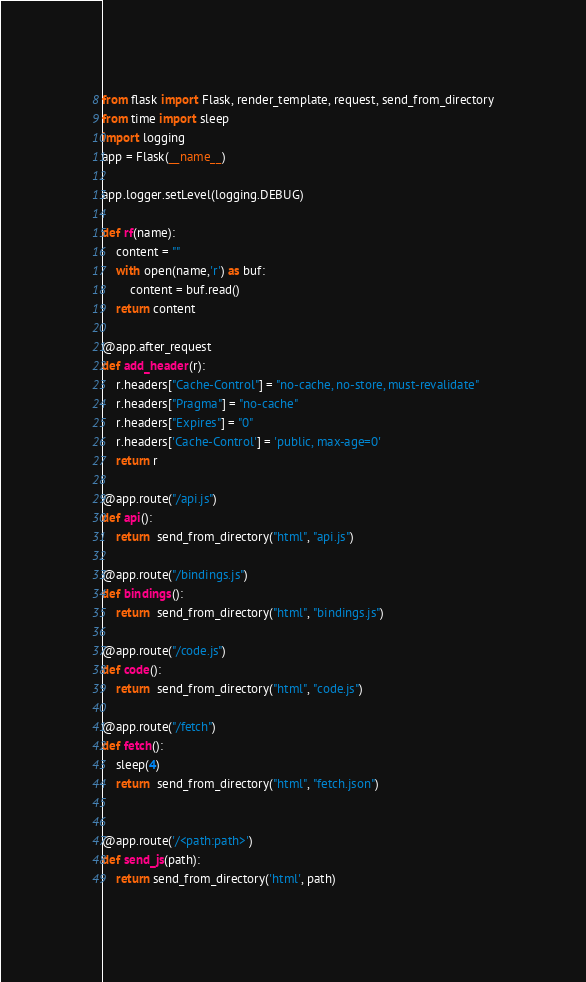Convert code to text. <code><loc_0><loc_0><loc_500><loc_500><_Python_>from flask import Flask, render_template, request, send_from_directory
from time import sleep
import logging
app = Flask(__name__)

app.logger.setLevel(logging.DEBUG)

def rf(name):
    content = ""
    with open(name,'r') as buf:
        content = buf.read()
    return content

@app.after_request
def add_header(r):
    r.headers["Cache-Control"] = "no-cache, no-store, must-revalidate"
    r.headers["Pragma"] = "no-cache"
    r.headers["Expires"] = "0"
    r.headers['Cache-Control'] = 'public, max-age=0'
    return r

@app.route("/api.js")
def api():
    return  send_from_directory("html", "api.js")

@app.route("/bindings.js")
def bindings():
    return  send_from_directory("html", "bindings.js")

@app.route("/code.js")
def code():
    return  send_from_directory("html", "code.js")

@app.route("/fetch")
def fetch():
    sleep(4)
    return  send_from_directory("html", "fetch.json")


@app.route('/<path:path>')
def send_js(path):
    return send_from_directory('html', path)
</code> 